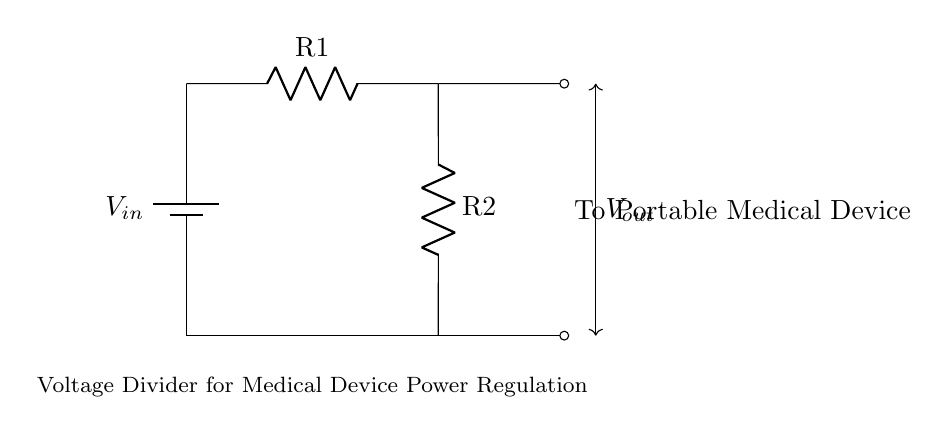What is the input voltage of the circuit? The circuit includes a battery symbol indicated as \(V_{in}\), signifying the input voltage. The exact value isn't specified, but it's labeled as \(V_{in}\).
Answer: \(V_{in}\) What are the two resistors in this voltage divider? The circuit diagram shows two resistors labeled as \(R1\) and \(R2\). These names signify their roles in the circuit.
Answer: \(R1\) and \(R2\) What is the output voltage from this voltage divider? The output voltage, \(V_{out}\), is indicated with arrows leading to the portable medical device. This shows where the divided voltage is implemented.
Answer: \(V_{out}\) Why are resistors used in this circuit? Resistors in a voltage divider are used to proportionally reduce the input voltage to a desired output voltage level suitable for the connected device.
Answer: To reduce voltage Where is the output from the voltage divider going? The output voltage is directed to a portable medical device, as indicated by the label next to the output node in the circuit diagram.
Answer: To Portable Medical Device What type of circuit is this? This circuit is a voltage divider specifically designed to regulate power supply, as indicated by the configuration of two resistors connected in series with a battery.
Answer: Voltage Divider What happens if one of the resistors fails? If one resistor fails, the voltage division will be affected, potentially leading to an improper voltage level for the output, which could malfunction the connected device.
Answer: Improper voltage level 